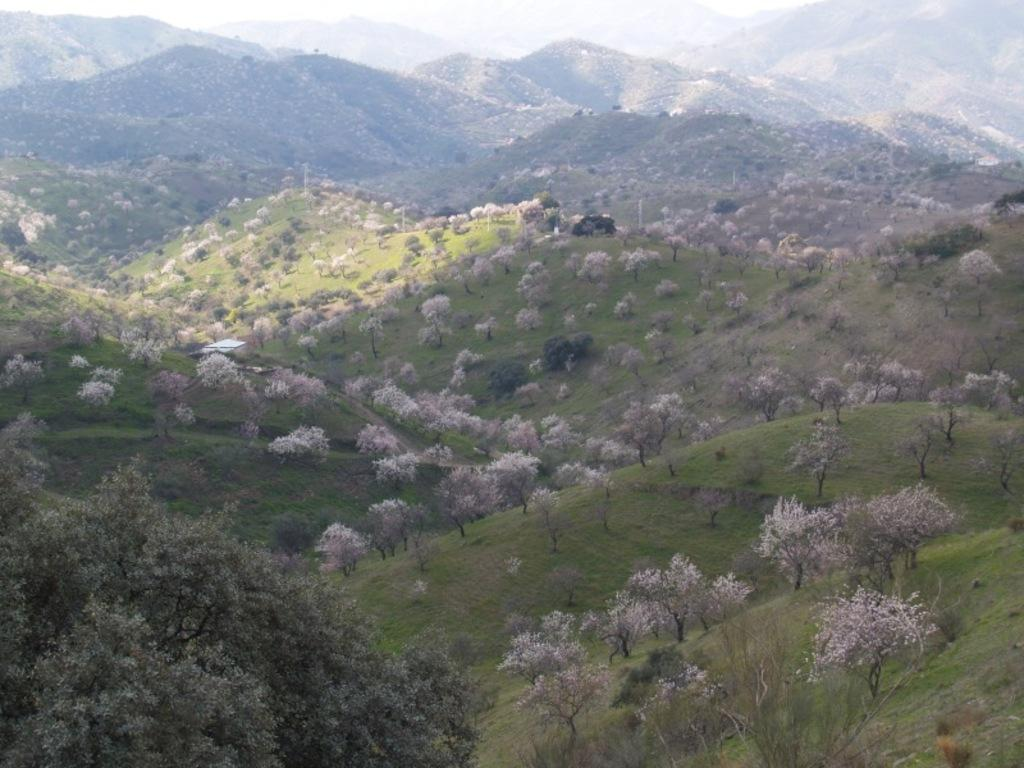What type of view is shown in the image? The image is an outside view. What geographical features can be seen in the image? There are many hills visible in the image. What type of vegetation is present in the image? There are trees on the ground in the image. How many dogs are visible in the image? There are no dogs present in the image. What type of coat is the duck wearing in the image? There are no ducks or coats present in the image. 